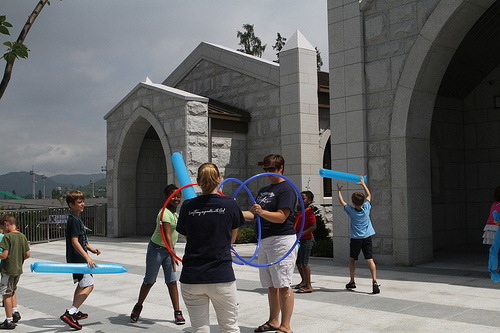<image>
Can you confirm if the tree is above the building? Yes. The tree is positioned above the building in the vertical space, higher up in the scene. 